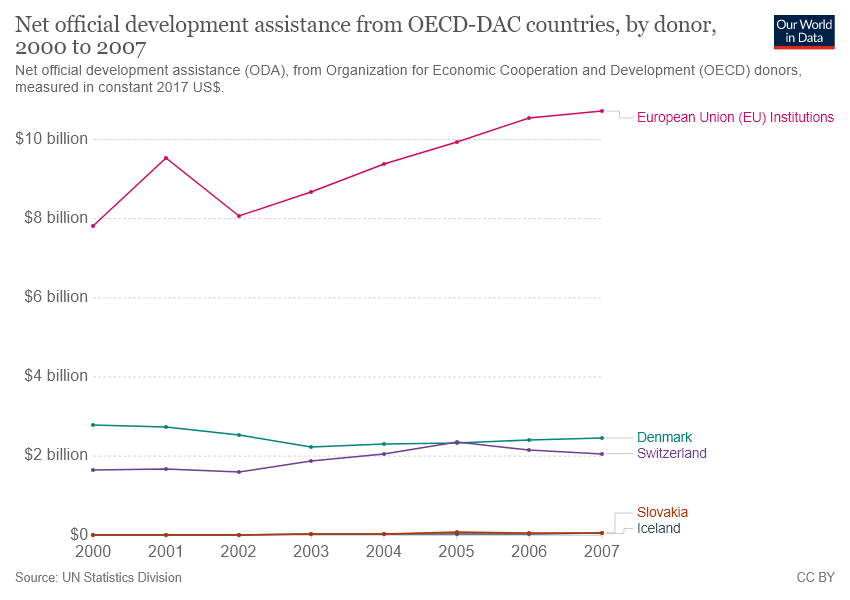Is the sum of official development assistance(ODA) for Denmark and Switzerland in 2000 greater than $4 billion? Based on the line graph depicting the net official development assistance (ODA) from OECD-DAC countries by donor from 2000 to 2007, the sum of ODA for Denmark and Switzerland in 2000 is not greater than $4 billion. The graph indicates that each country contributed significantly less than $2 billion individually, so their combined contribution would also be less than $4 billion for that year. 